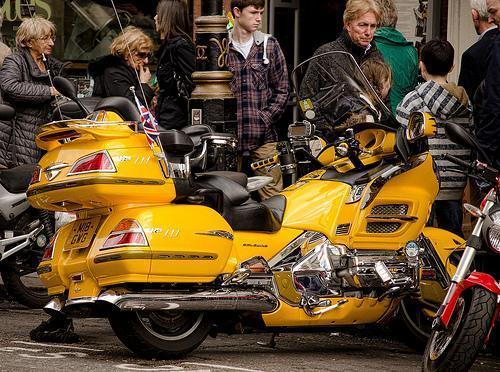How many people are in the image?
Give a very brief answer. 10. 